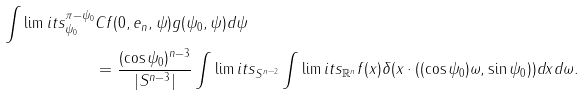<formula> <loc_0><loc_0><loc_500><loc_500>\int \lim i t s _ { \psi _ { 0 } } ^ { \pi - \psi _ { 0 } } & C f ( 0 , e _ { n } , \psi ) g ( \psi _ { 0 } , \psi ) d \psi \\ & = \frac { ( \cos \psi _ { 0 } ) ^ { n - 3 } } { | S ^ { n - 3 } | } \int \lim i t s _ { S ^ { n - 2 } } \int \lim i t s _ { \mathbb { R } ^ { n } } f ( x ) \delta ( x \cdot ( ( \cos \psi _ { 0 } ) \omega , \sin \psi _ { 0 } ) ) d x d \omega .</formula> 